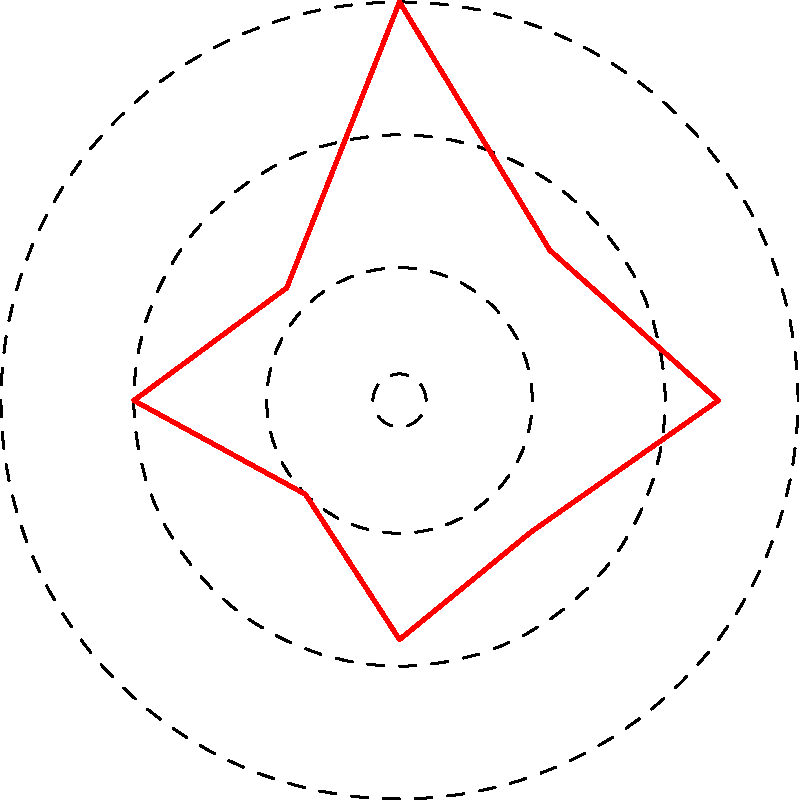In a recent investigation of an ancient bronze weapon, you plotted the concentration of trace elements on a polar chart. The chart shows the distribution of a particular trace element at different angles around the weapon's cross-section. If the highest concentration is found at 90° and the lowest at 225°, what is the difference in concentration (in ppm) between these two points? To solve this problem, we need to follow these steps:

1. Identify the concentrations at 90° and 225° from the polar chart:
   - At 90°, the concentration is 15 ppm
   - At 225°, the concentration is 5 ppm

2. Calculate the difference between these two concentrations:
   $15 \text{ ppm} - 5 \text{ ppm} = 10 \text{ ppm}$

The polar chart represents the concentration of trace elements at different angles in the cross-section of the ancient bronze weapon. Each concentric circle represents a concentration level, with the outermost circle at 15 ppm and the innermost at 5 ppm.

The highest point on the chart is at 90°, touching the 15 ppm circle, while the lowest point is at 225°, touching the 5 ppm circle. The difference between these two points represents the range of concentration for this particular trace element in the weapon's cross-section.

This information can be crucial in forensic analysis, as it may indicate the manufacturing process, the origin of the metal, or potential areas of wear or corrosion in the ancient weapon.
Answer: 10 ppm 